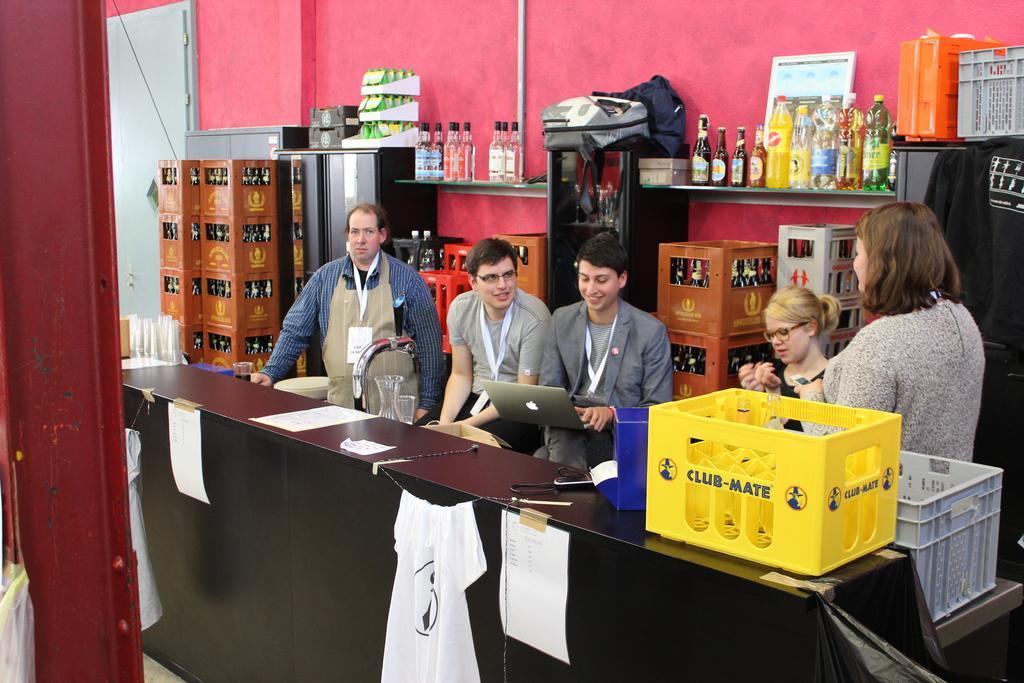Provide a one-sentence caption for the provided image. Five people sit behind a desk with a yellow container that states CLUB-MATE to the left side of them. 